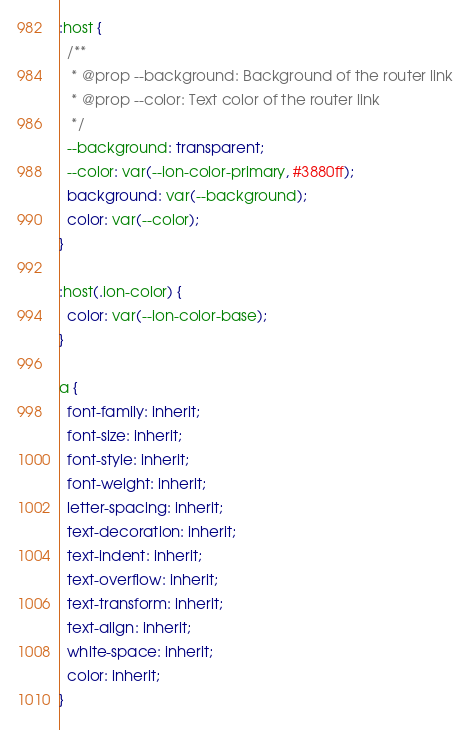Convert code to text. <code><loc_0><loc_0><loc_500><loc_500><_CSS_>:host {
  /**
   * @prop --background: Background of the router link
   * @prop --color: Text color of the router link
   */
  --background: transparent;
  --color: var(--ion-color-primary, #3880ff);
  background: var(--background);
  color: var(--color);
}

:host(.ion-color) {
  color: var(--ion-color-base);
}

a {
  font-family: inherit;
  font-size: inherit;
  font-style: inherit;
  font-weight: inherit;
  letter-spacing: inherit;
  text-decoration: inherit;
  text-indent: inherit;
  text-overflow: inherit;
  text-transform: inherit;
  text-align: inherit;
  white-space: inherit;
  color: inherit;
}</code> 